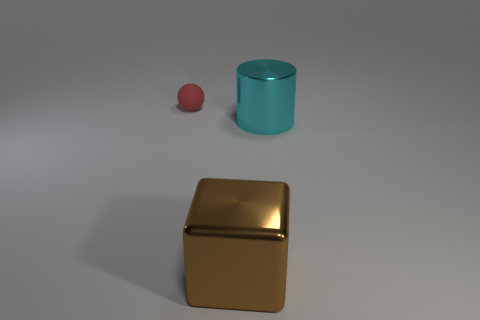Are there any other things that are the same size as the sphere?
Provide a succinct answer. No. Are there more metallic cylinders that are in front of the cyan object than brown things?
Ensure brevity in your answer.  No. How many things are objects that are to the left of the shiny cube or purple rubber cylinders?
Offer a very short reply. 1. How many large objects are made of the same material as the brown cube?
Keep it short and to the point. 1. Is there a brown metallic object of the same shape as the rubber thing?
Ensure brevity in your answer.  No. The other shiny object that is the same size as the brown shiny object is what shape?
Make the answer very short. Cylinder. How many small red matte objects are behind the shiny thing to the right of the big brown metallic thing?
Your answer should be compact. 1. There is a object that is both to the right of the small red rubber sphere and to the left of the big cyan shiny cylinder; how big is it?
Your response must be concise. Large. Are there any metal objects that have the same size as the brown cube?
Provide a short and direct response. Yes. Are there more things that are in front of the red rubber object than blocks behind the big block?
Ensure brevity in your answer.  Yes. 